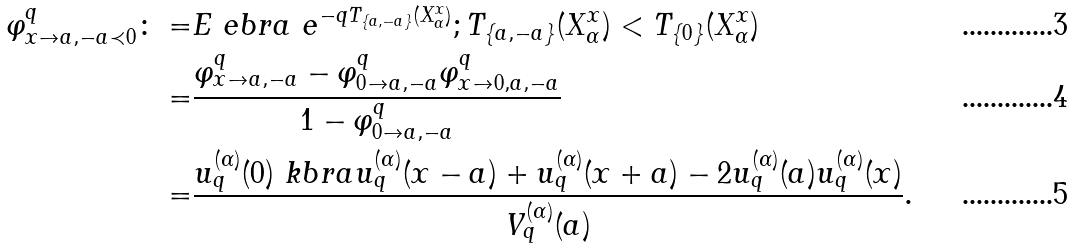<formula> <loc_0><loc_0><loc_500><loc_500>\varphi ^ { q } _ { x \to a , - a \prec 0 } \colon = & E \ e b r a { \ e ^ { - q T _ { \{ a , - a \} } ( X ^ { x } _ { \alpha } ) } ; T _ { \{ a , - a \} } ( X ^ { x } _ { \alpha } ) < T _ { \{ 0 \} } ( X ^ { x } _ { \alpha } ) } \\ = & \frac { \varphi ^ { q } _ { x \to a , - a } - \varphi ^ { q } _ { 0 \to a , - a } \varphi ^ { q } _ { x \to 0 , a , - a } } { 1 - \varphi ^ { q } _ { 0 \to a , - a } } \\ = & \frac { u ^ { ( \alpha ) } _ { q } ( 0 ) \ k b r a { u ^ { ( \alpha ) } _ { q } ( x - a ) + u ^ { ( \alpha ) } _ { q } ( x + a ) } - 2 u ^ { ( \alpha ) } _ { q } ( a ) u ^ { ( \alpha ) } _ { q } ( x ) } { V ^ { ( \alpha ) } _ { q } ( a ) } .</formula> 